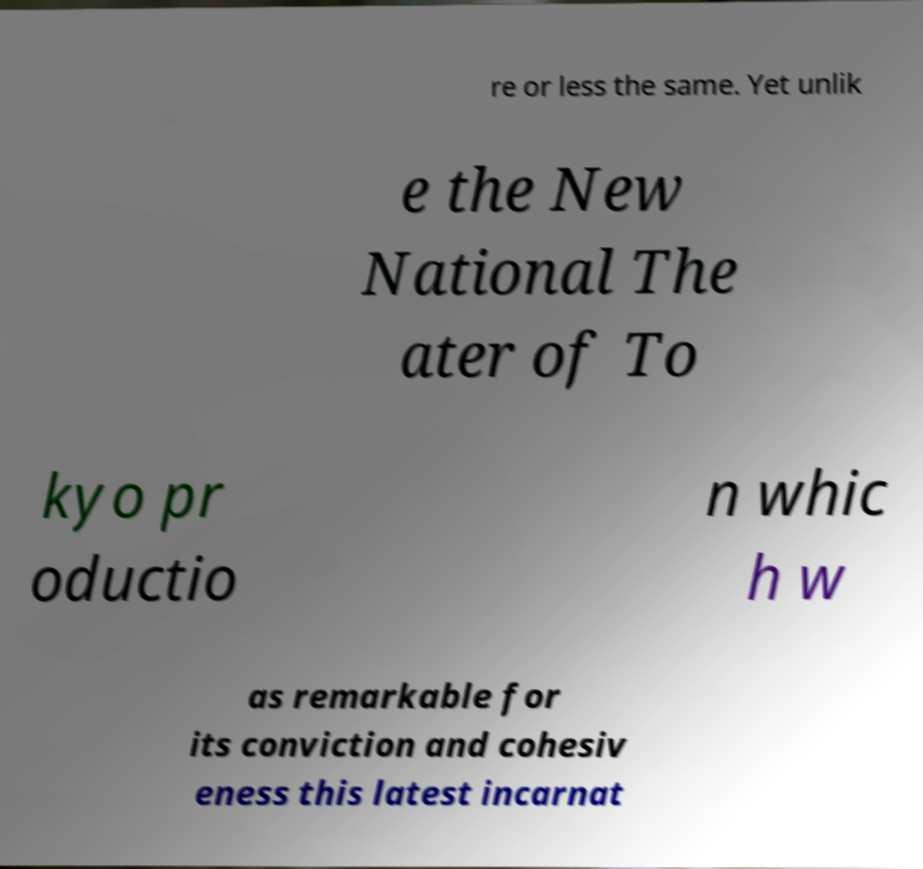Could you extract and type out the text from this image? re or less the same. Yet unlik e the New National The ater of To kyo pr oductio n whic h w as remarkable for its conviction and cohesiv eness this latest incarnat 